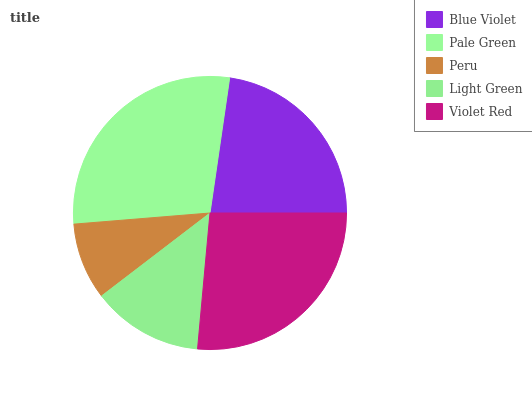Is Peru the minimum?
Answer yes or no. Yes. Is Pale Green the maximum?
Answer yes or no. Yes. Is Pale Green the minimum?
Answer yes or no. No. Is Peru the maximum?
Answer yes or no. No. Is Pale Green greater than Peru?
Answer yes or no. Yes. Is Peru less than Pale Green?
Answer yes or no. Yes. Is Peru greater than Pale Green?
Answer yes or no. No. Is Pale Green less than Peru?
Answer yes or no. No. Is Blue Violet the high median?
Answer yes or no. Yes. Is Blue Violet the low median?
Answer yes or no. Yes. Is Violet Red the high median?
Answer yes or no. No. Is Light Green the low median?
Answer yes or no. No. 